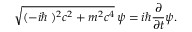Convert formula to latex. <formula><loc_0><loc_0><loc_500><loc_500>{ \sqrt { ( - i \hbar { \nabla } ) ^ { 2 } c ^ { 2 } + m ^ { 2 } c ^ { 4 } } } \, \psi = i \hbar { \frac { \partial } { \partial t } } \psi .</formula> 